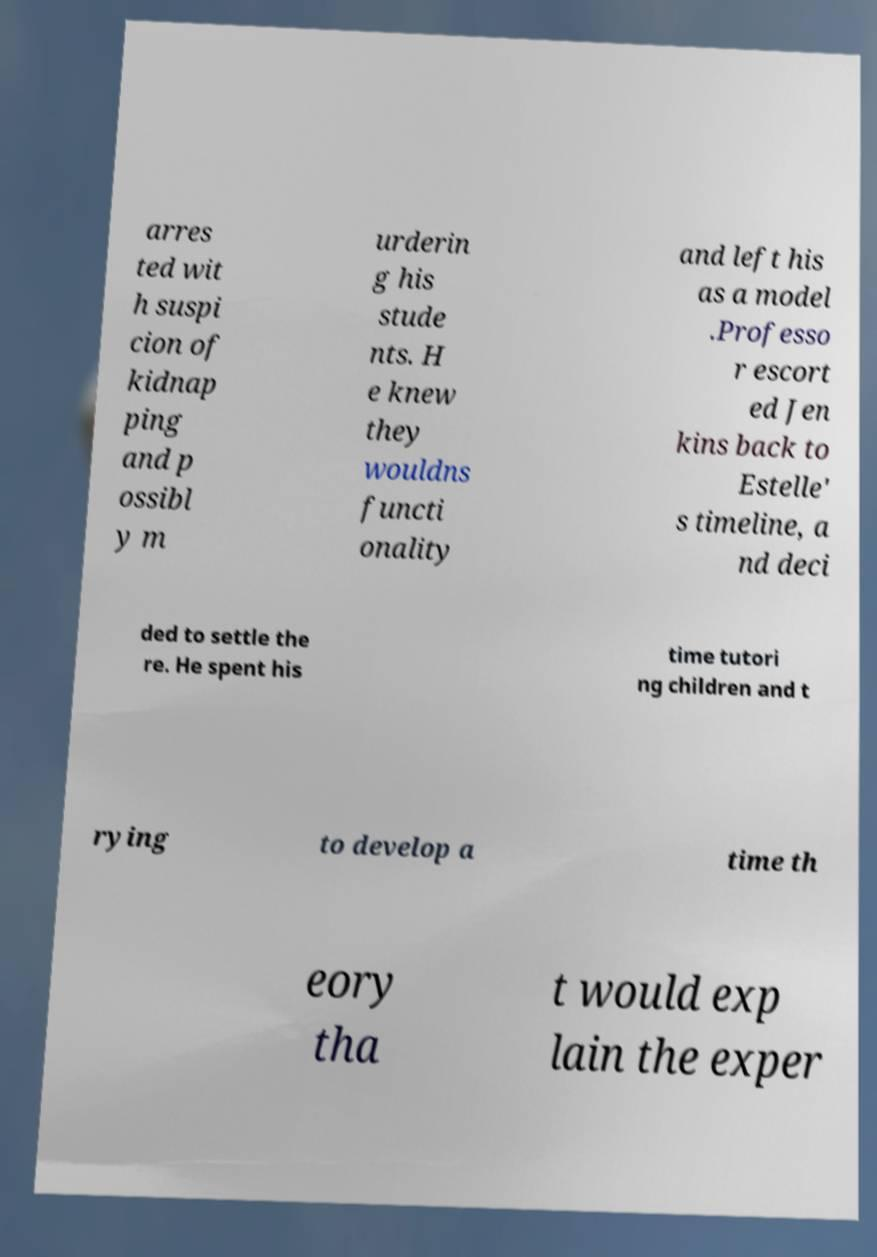Can you read and provide the text displayed in the image?This photo seems to have some interesting text. Can you extract and type it out for me? arres ted wit h suspi cion of kidnap ping and p ossibl y m urderin g his stude nts. H e knew they wouldns functi onality and left his as a model .Professo r escort ed Jen kins back to Estelle' s timeline, a nd deci ded to settle the re. He spent his time tutori ng children and t rying to develop a time th eory tha t would exp lain the exper 